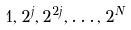Convert formula to latex. <formula><loc_0><loc_0><loc_500><loc_500>1 , 2 ^ { j } , 2 ^ { 2 j } , \dots , 2 ^ { N }</formula> 